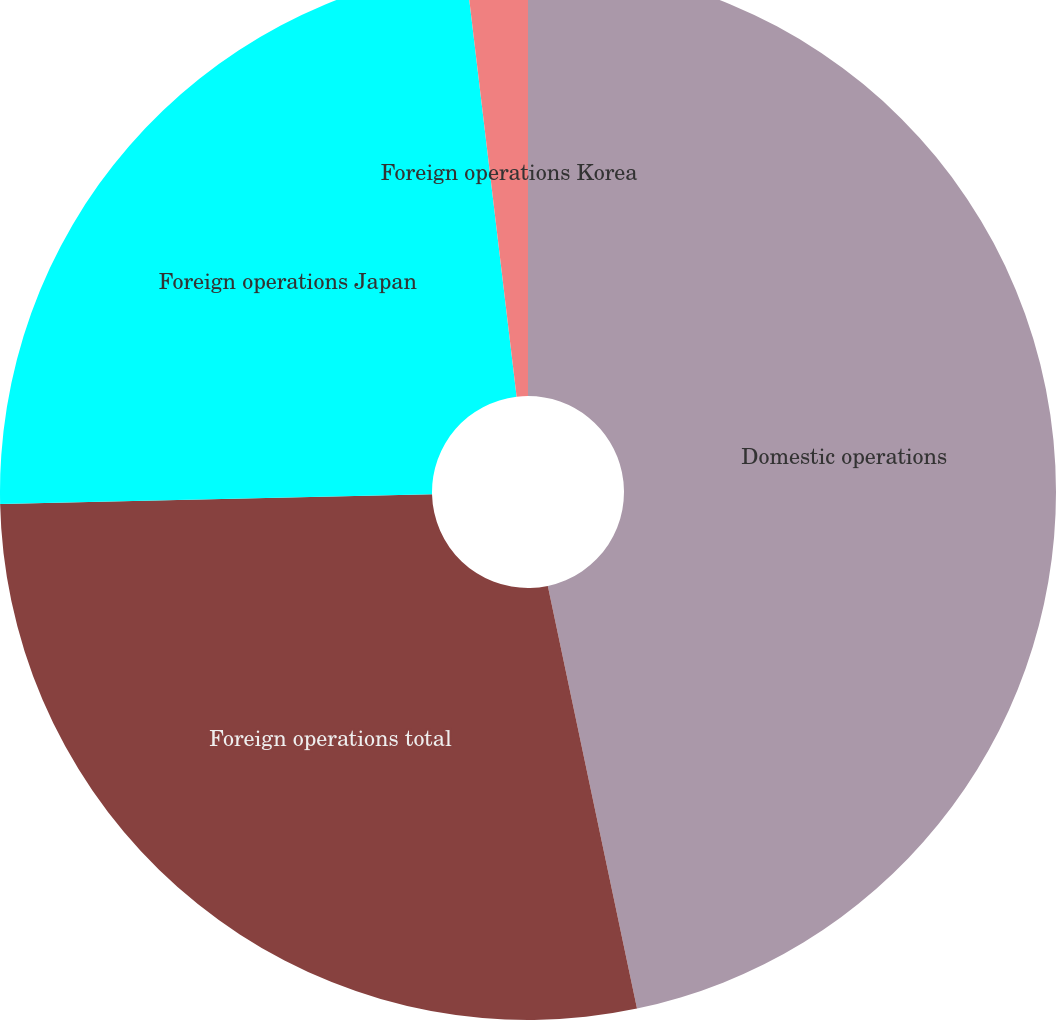<chart> <loc_0><loc_0><loc_500><loc_500><pie_chart><fcel>Domestic operations<fcel>Foreign operations total<fcel>Foreign operations Japan<fcel>Foreign operations Korea<nl><fcel>46.69%<fcel>27.95%<fcel>23.47%<fcel>1.89%<nl></chart> 